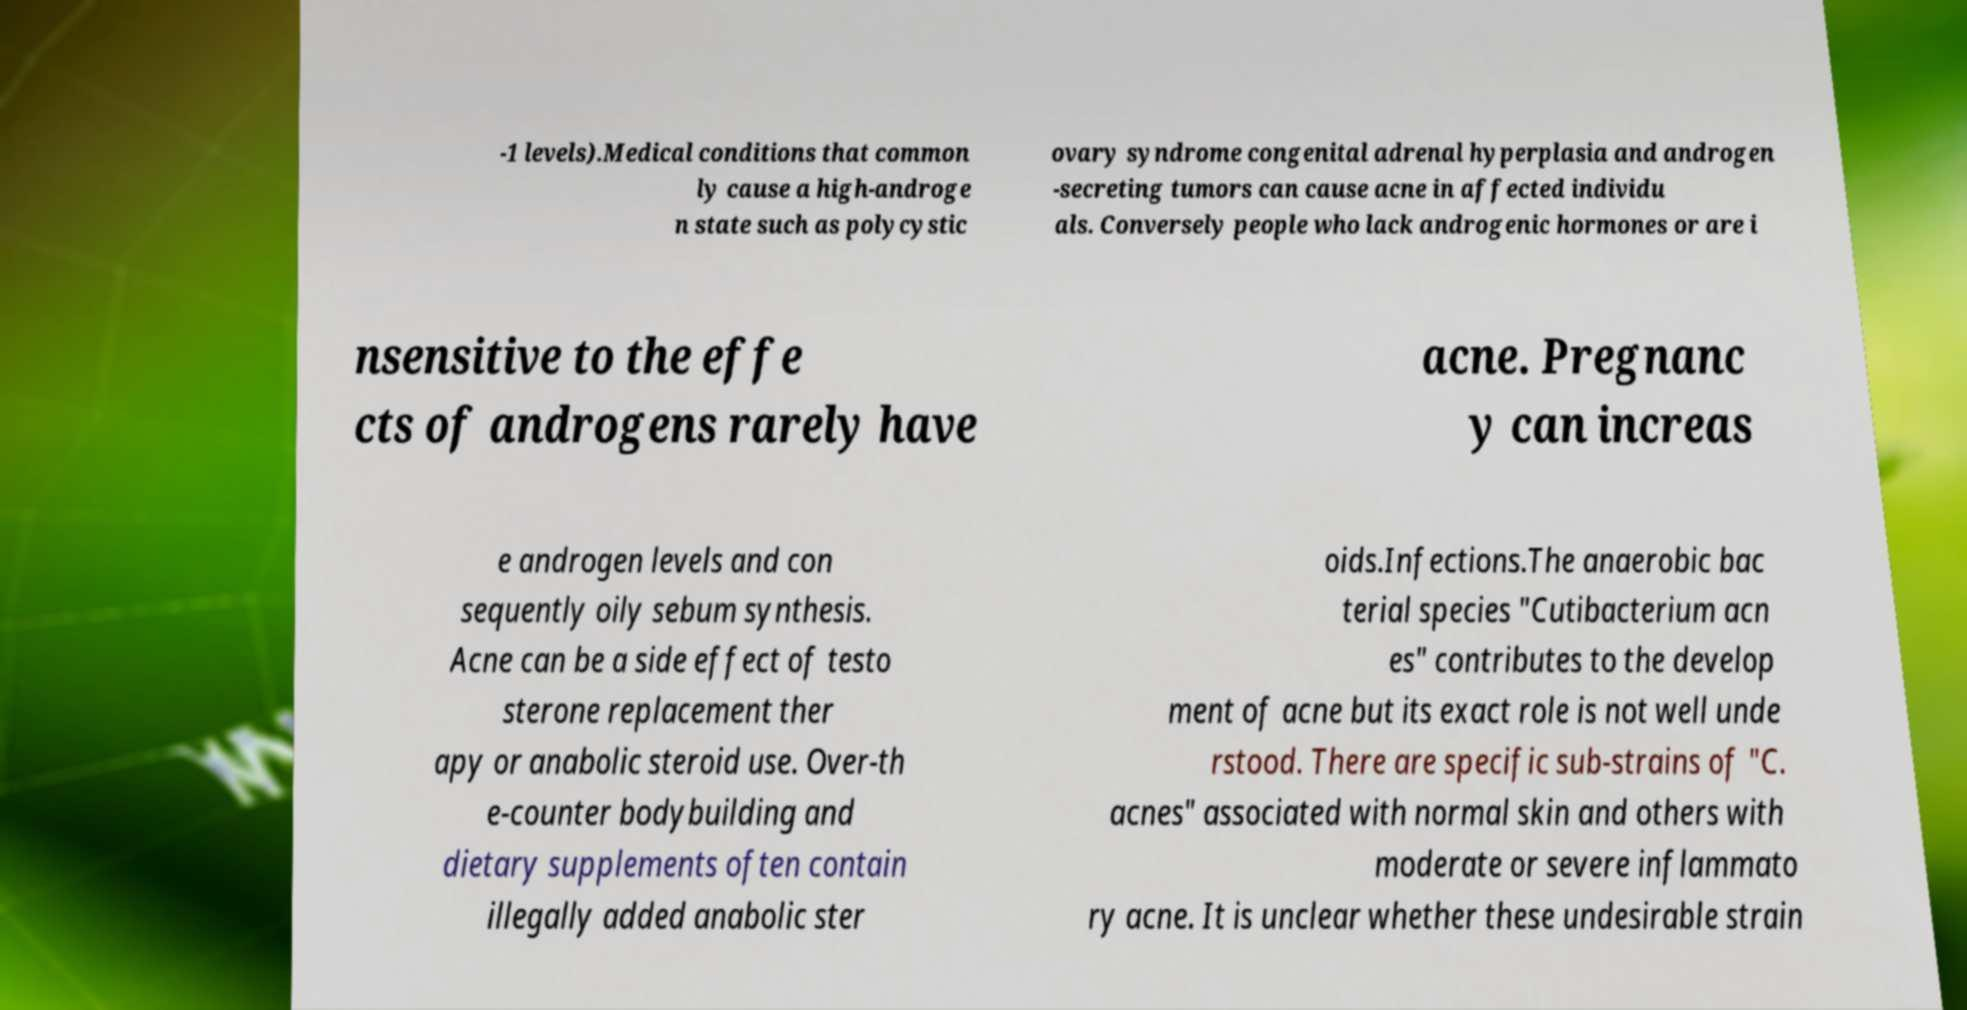I need the written content from this picture converted into text. Can you do that? -1 levels).Medical conditions that common ly cause a high-androge n state such as polycystic ovary syndrome congenital adrenal hyperplasia and androgen -secreting tumors can cause acne in affected individu als. Conversely people who lack androgenic hormones or are i nsensitive to the effe cts of androgens rarely have acne. Pregnanc y can increas e androgen levels and con sequently oily sebum synthesis. Acne can be a side effect of testo sterone replacement ther apy or anabolic steroid use. Over-th e-counter bodybuilding and dietary supplements often contain illegally added anabolic ster oids.Infections.The anaerobic bac terial species "Cutibacterium acn es" contributes to the develop ment of acne but its exact role is not well unde rstood. There are specific sub-strains of "C. acnes" associated with normal skin and others with moderate or severe inflammato ry acne. It is unclear whether these undesirable strain 